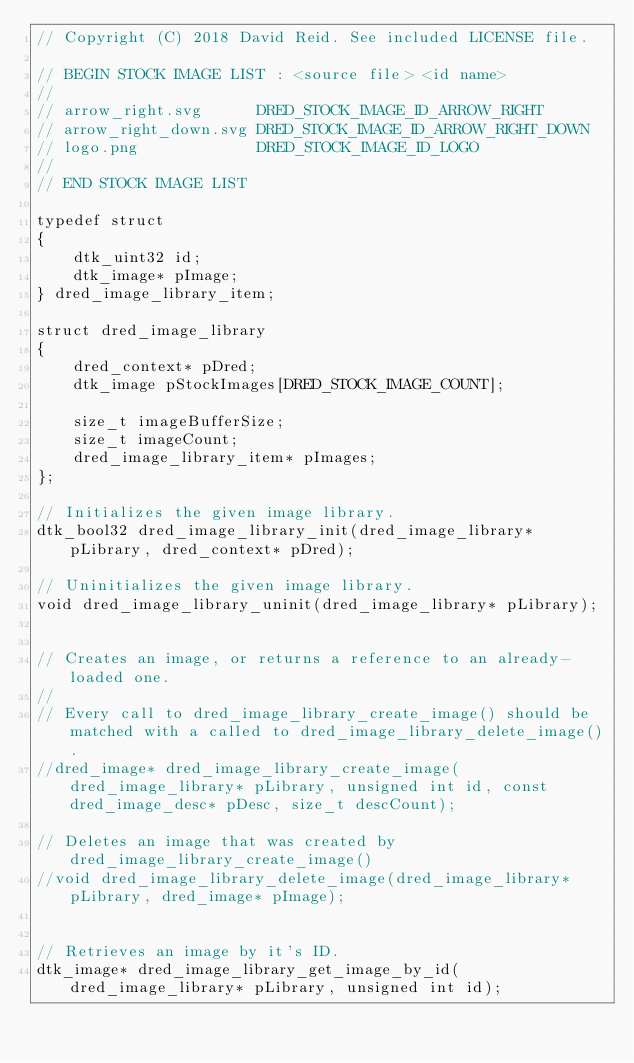<code> <loc_0><loc_0><loc_500><loc_500><_C_>// Copyright (C) 2018 David Reid. See included LICENSE file.

// BEGIN STOCK IMAGE LIST : <source file> <id name>
//
// arrow_right.svg      DRED_STOCK_IMAGE_ID_ARROW_RIGHT
// arrow_right_down.svg DRED_STOCK_IMAGE_ID_ARROW_RIGHT_DOWN
// logo.png             DRED_STOCK_IMAGE_ID_LOGO
//
// END STOCK IMAGE LIST

typedef struct
{
    dtk_uint32 id;
    dtk_image* pImage;
} dred_image_library_item;

struct dred_image_library
{
    dred_context* pDred;
    dtk_image pStockImages[DRED_STOCK_IMAGE_COUNT];

    size_t imageBufferSize;
    size_t imageCount;
    dred_image_library_item* pImages;
};

// Initializes the given image library.
dtk_bool32 dred_image_library_init(dred_image_library* pLibrary, dred_context* pDred);

// Uninitializes the given image library.
void dred_image_library_uninit(dred_image_library* pLibrary);


// Creates an image, or returns a reference to an already-loaded one.
//
// Every call to dred_image_library_create_image() should be matched with a called to dred_image_library_delete_image().
//dred_image* dred_image_library_create_image(dred_image_library* pLibrary, unsigned int id, const dred_image_desc* pDesc, size_t descCount);

// Deletes an image that was created by dred_image_library_create_image()
//void dred_image_library_delete_image(dred_image_library* pLibrary, dred_image* pImage);


// Retrieves an image by it's ID.
dtk_image* dred_image_library_get_image_by_id(dred_image_library* pLibrary, unsigned int id);</code> 